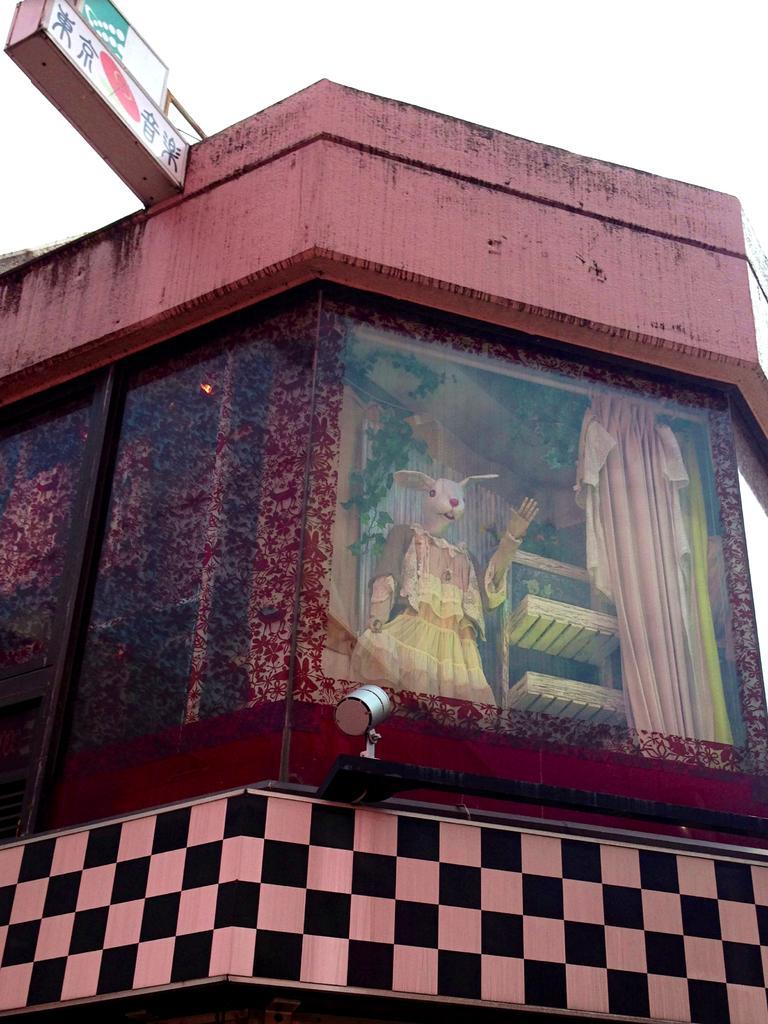Please provide a concise description of this image. In this image there is a building and we can see a mannequin, stand and a curtain through the glass door. In the background there is sky and we can see a board. 